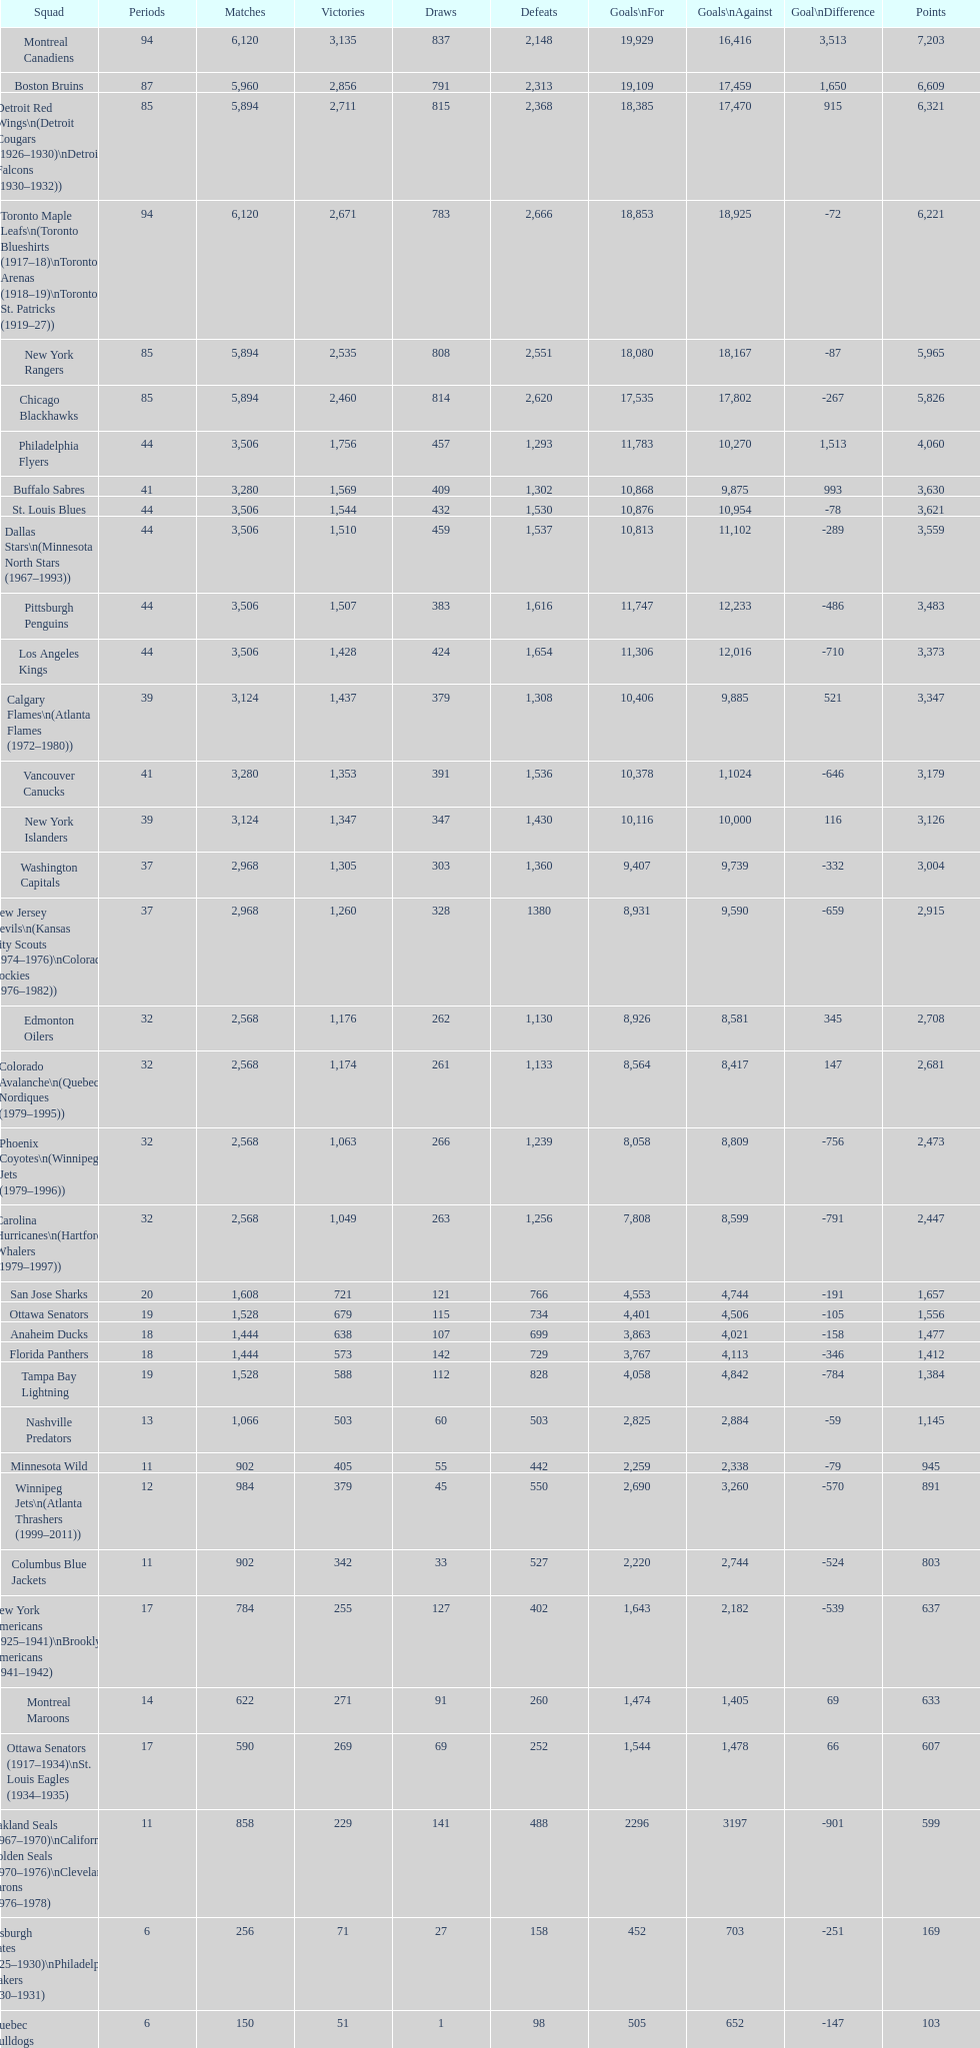How many losses do the st. louis blues have? 1,530. 